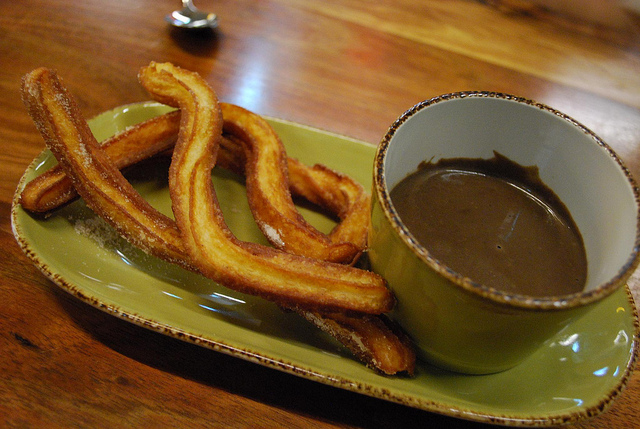What is present? Churros are present on the plate, accompanied by a cup containing what appears to be chocolate sauce. 